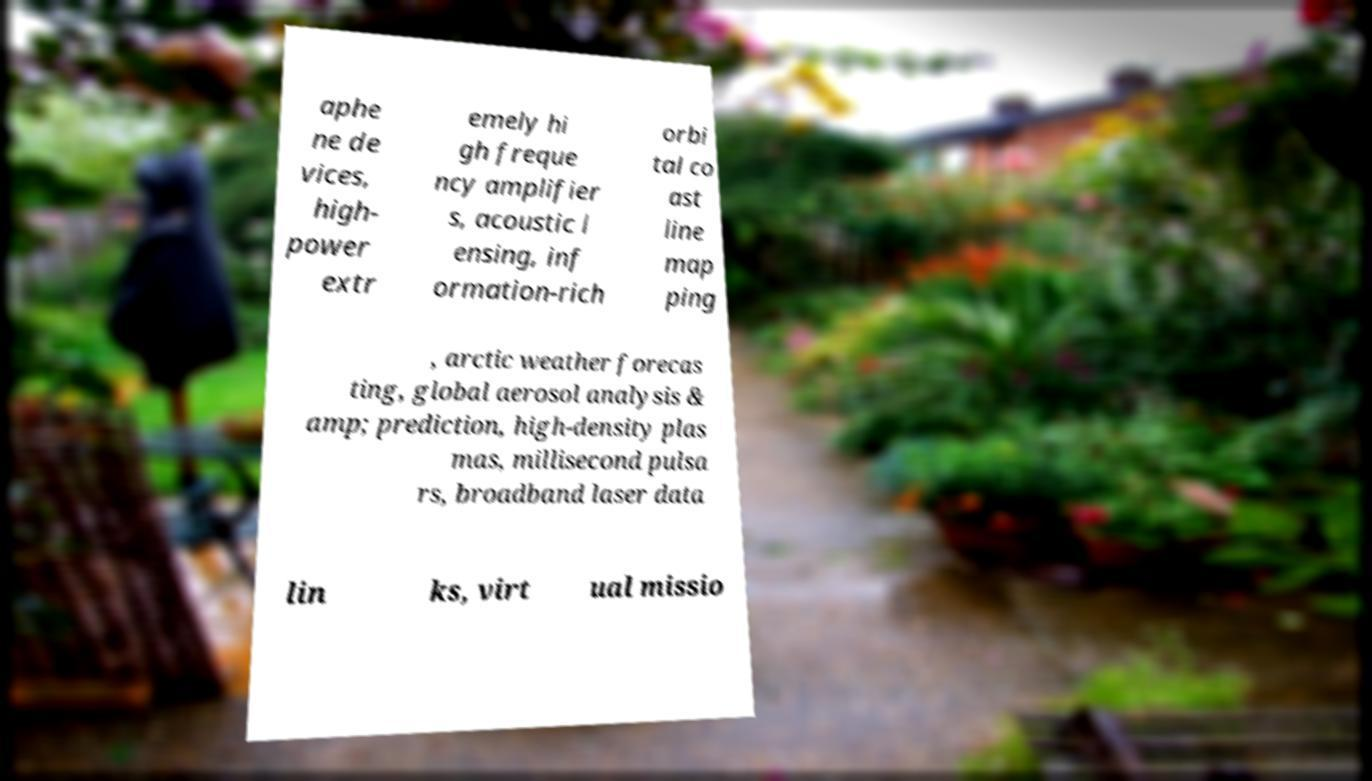Could you extract and type out the text from this image? aphe ne de vices, high- power extr emely hi gh freque ncy amplifier s, acoustic l ensing, inf ormation-rich orbi tal co ast line map ping , arctic weather forecas ting, global aerosol analysis & amp; prediction, high-density plas mas, millisecond pulsa rs, broadband laser data lin ks, virt ual missio 